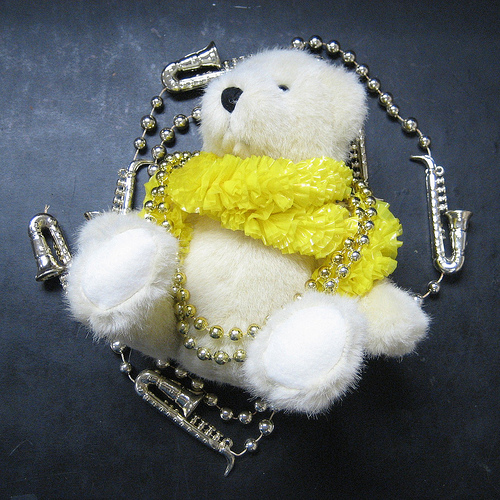<image>
Is there a doll next to the earth? No. The doll is not positioned next to the earth. They are located in different areas of the scene. Where is the toy in relation to the floor? Is it on the floor? Yes. Looking at the image, I can see the toy is positioned on top of the floor, with the floor providing support. 